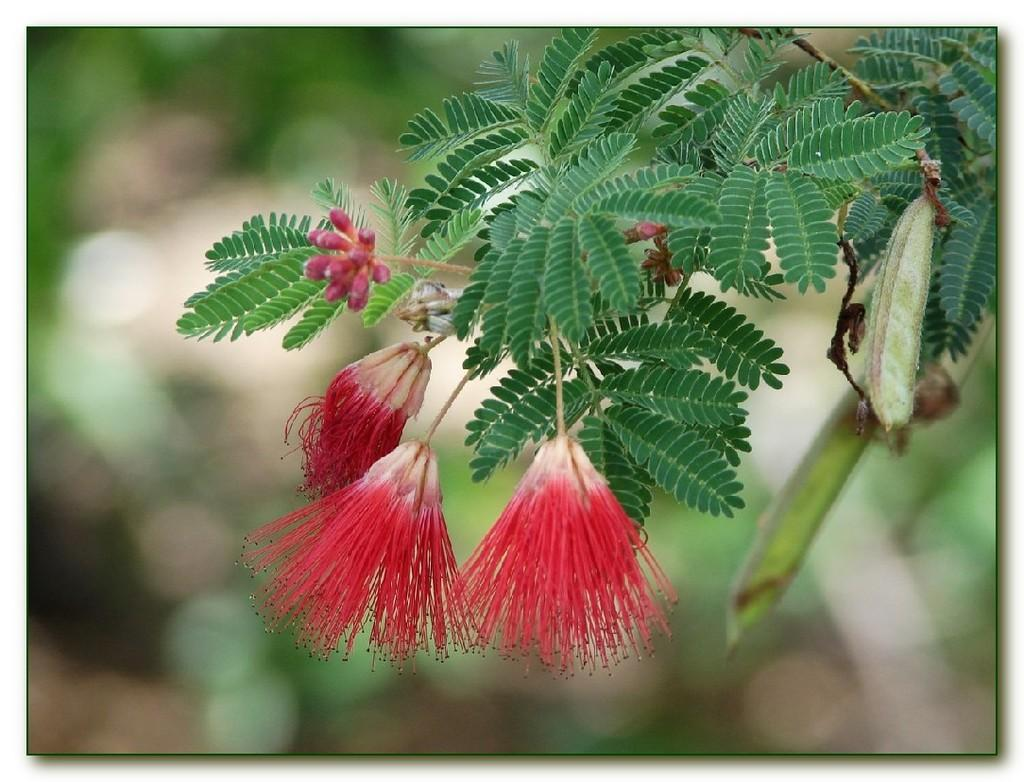What type of flowers can be seen in the image? There are red color flowers in the image. What color are the leaves in the image? There are green color leaves in the image. Can you describe the background of the image? The background of the image is blurred. What type of nut is being used to play music in the image? There is no nut or music present in the image; it features red flowers and green leaves with a blurred background. 